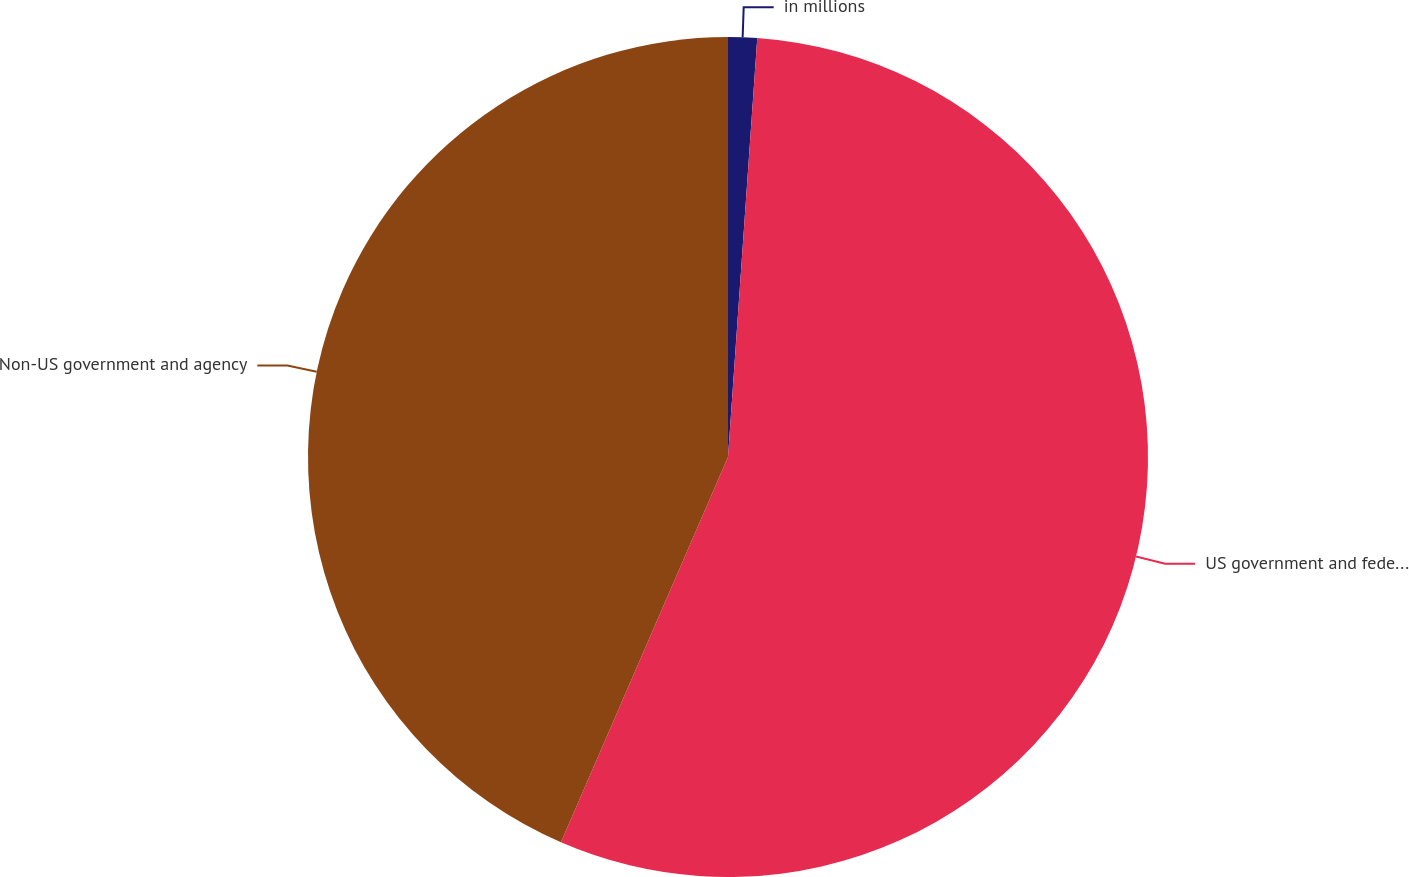Convert chart to OTSL. <chart><loc_0><loc_0><loc_500><loc_500><pie_chart><fcel>in millions<fcel>US government and federal<fcel>Non-US government and agency<nl><fcel>1.11%<fcel>55.4%<fcel>43.49%<nl></chart> 